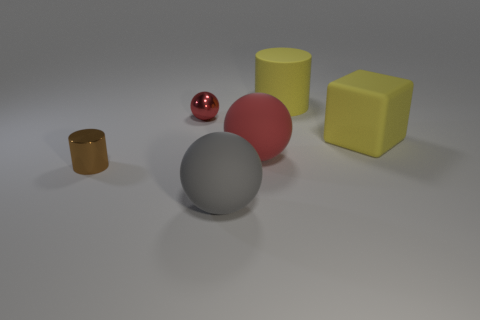Add 3 big red spheres. How many objects exist? 9 Subtract all cylinders. How many objects are left? 4 Add 6 balls. How many balls are left? 9 Add 4 metallic spheres. How many metallic spheres exist? 5 Subtract 0 blue balls. How many objects are left? 6 Subtract all gray rubber objects. Subtract all small red shiny balls. How many objects are left? 4 